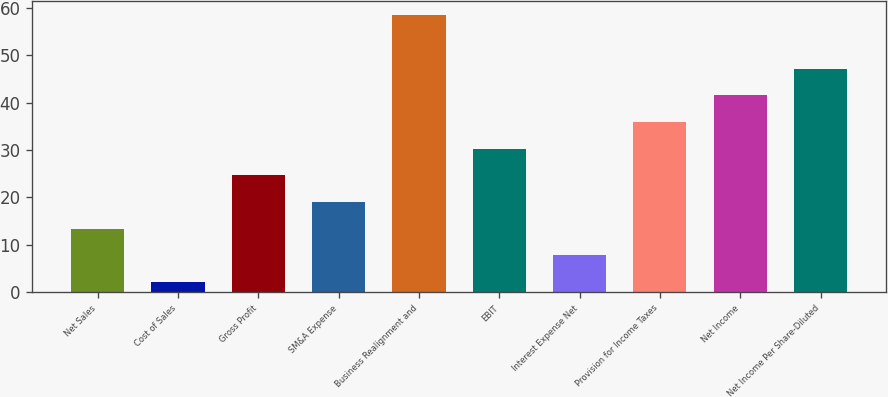Convert chart to OTSL. <chart><loc_0><loc_0><loc_500><loc_500><bar_chart><fcel>Net Sales<fcel>Cost of Sales<fcel>Gross Profit<fcel>SM&A Expense<fcel>Business Realignment and<fcel>EBIT<fcel>Interest Expense Net<fcel>Provision for Income Taxes<fcel>Net Income<fcel>Net Income Per Share-Diluted<nl><fcel>13.38<fcel>2.1<fcel>24.66<fcel>19.02<fcel>58.5<fcel>30.3<fcel>7.74<fcel>35.94<fcel>41.58<fcel>47.22<nl></chart> 